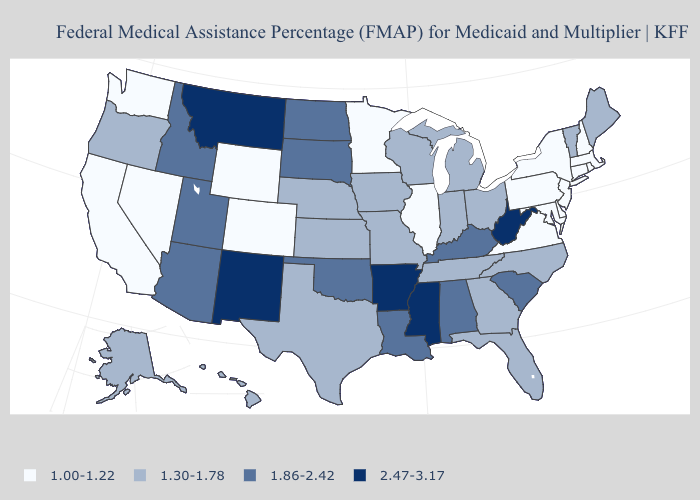What is the value of Connecticut?
Be succinct. 1.00-1.22. What is the highest value in states that border Utah?
Quick response, please. 2.47-3.17. What is the value of Maryland?
Be succinct. 1.00-1.22. What is the value of Washington?
Answer briefly. 1.00-1.22. Does South Dakota have the highest value in the MidWest?
Be succinct. Yes. Does Nebraska have the same value as Colorado?
Give a very brief answer. No. What is the highest value in the USA?
Give a very brief answer. 2.47-3.17. What is the highest value in the MidWest ?
Write a very short answer. 1.86-2.42. Among the states that border Wisconsin , which have the lowest value?
Give a very brief answer. Illinois, Minnesota. What is the value of Vermont?
Give a very brief answer. 1.30-1.78. How many symbols are there in the legend?
Short answer required. 4. Name the states that have a value in the range 1.86-2.42?
Keep it brief. Alabama, Arizona, Idaho, Kentucky, Louisiana, North Dakota, Oklahoma, South Carolina, South Dakota, Utah. Among the states that border Illinois , which have the lowest value?
Give a very brief answer. Indiana, Iowa, Missouri, Wisconsin. Name the states that have a value in the range 2.47-3.17?
Write a very short answer. Arkansas, Mississippi, Montana, New Mexico, West Virginia. 